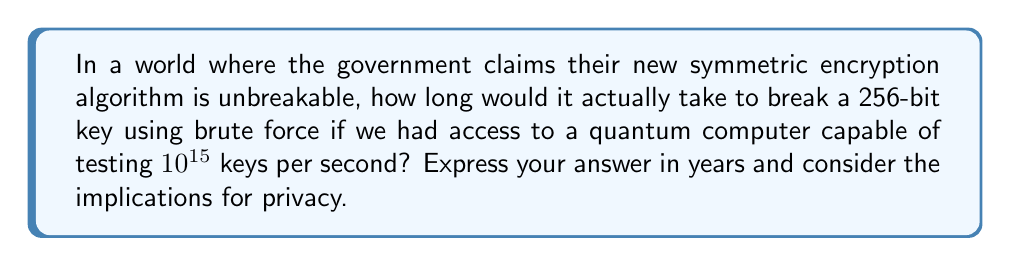What is the answer to this math problem? Let's approach this step-by-step:

1) First, we need to calculate the total number of possible keys for a 256-bit encryption:
   $$2^{256} = 1.1579 \times 10^{77}$$ possible keys

2) Now, let's consider the speed of our hypothetical quantum computer:
   $$10^{15}$$ keys per second

3) To find the time needed, we divide the total number of keys by the number of keys tested per second:
   $$\frac{1.1579 \times 10^{77}}{10^{15}} = 1.1579 \times 10^{62}$$ seconds

4) Convert seconds to years:
   $$\frac{1.1579 \times 10^{62}}{60 \times 60 \times 24 \times 365.25} = 3.6710 \times 10^{54}$$ years

5) This is an astronomically large number, far exceeding the current age of the universe (approximately $13.8 \times 10^9$ years).

The implications for privacy are significant. While the government claims the algorithm is unbreakable, this calculation shows that it is theoretically breakable, but would take an impractical amount of time even with advanced quantum computing. However, this doesn't account for potential weaknesses in the algorithm's implementation or future technological advancements that could dramatically reduce this time.
Answer: $3.6710 \times 10^{54}$ years 